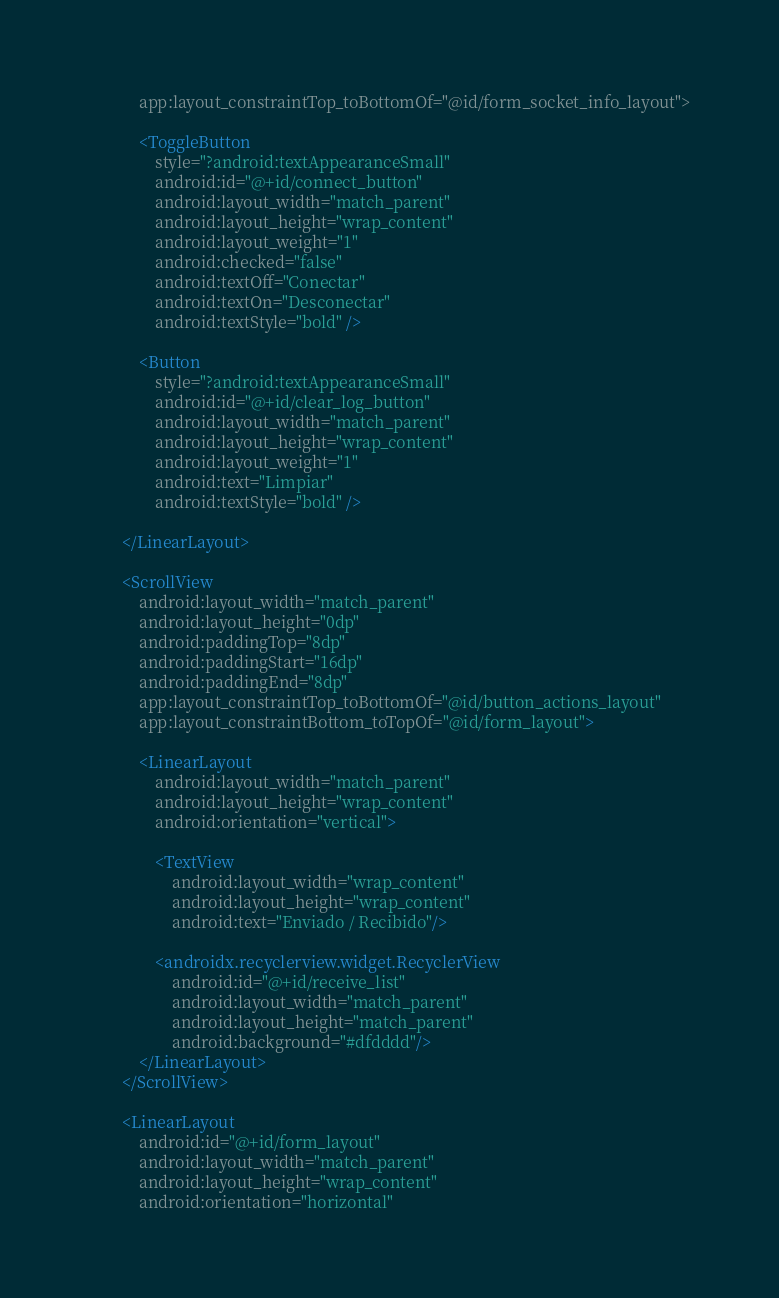Convert code to text. <code><loc_0><loc_0><loc_500><loc_500><_XML_>            app:layout_constraintTop_toBottomOf="@id/form_socket_info_layout">

            <ToggleButton
                style="?android:textAppearanceSmall"
                android:id="@+id/connect_button"
                android:layout_width="match_parent"
                android:layout_height="wrap_content"
                android:layout_weight="1"
                android:checked="false"
                android:textOff="Conectar"
                android:textOn="Desconectar"
                android:textStyle="bold" />

            <Button
                style="?android:textAppearanceSmall"
                android:id="@+id/clear_log_button"
                android:layout_width="match_parent"
                android:layout_height="wrap_content"
                android:layout_weight="1"
                android:text="Limpiar"
                android:textStyle="bold" />

        </LinearLayout>

        <ScrollView
            android:layout_width="match_parent"
            android:layout_height="0dp"
            android:paddingTop="8dp"
            android:paddingStart="16dp"
            android:paddingEnd="8dp"
            app:layout_constraintTop_toBottomOf="@id/button_actions_layout"
            app:layout_constraintBottom_toTopOf="@id/form_layout">

            <LinearLayout
                android:layout_width="match_parent"
                android:layout_height="wrap_content"
                android:orientation="vertical">

                <TextView
                    android:layout_width="wrap_content"
                    android:layout_height="wrap_content"
                    android:text="Enviado / Recibido"/>

                <androidx.recyclerview.widget.RecyclerView
                    android:id="@+id/receive_list"
                    android:layout_width="match_parent"
                    android:layout_height="match_parent"
                    android:background="#dfdddd"/>
            </LinearLayout>
        </ScrollView>

        <LinearLayout
            android:id="@+id/form_layout"
            android:layout_width="match_parent"
            android:layout_height="wrap_content"
            android:orientation="horizontal"</code> 